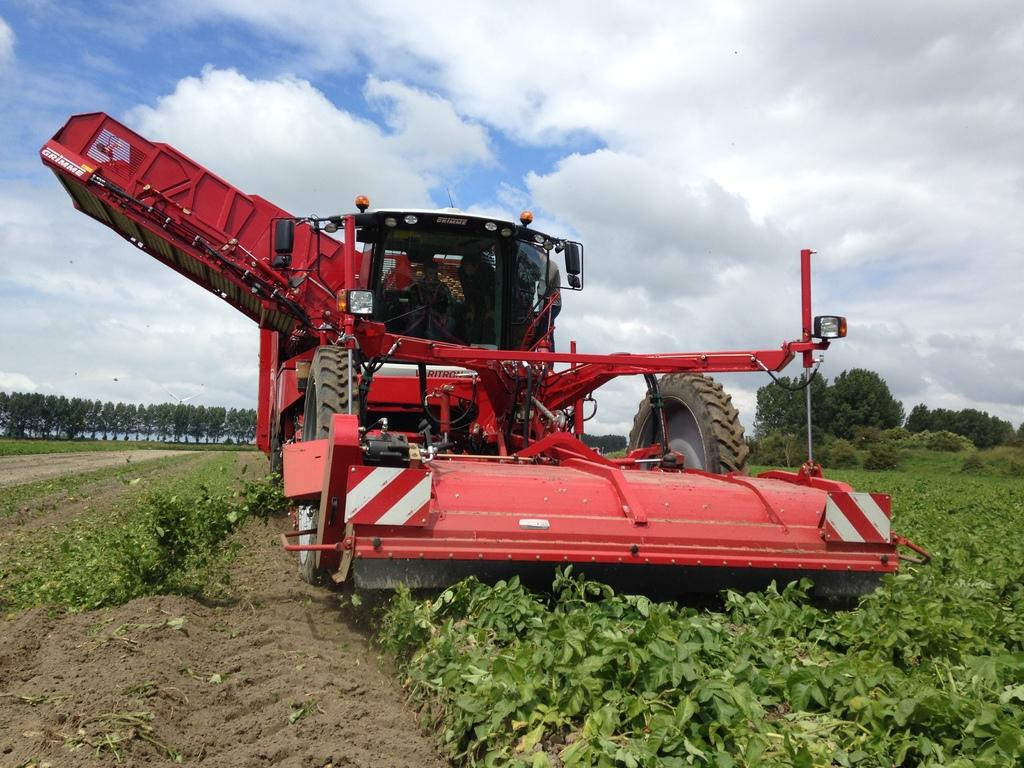What type of terrain is visible in the image? There is an open grass ground in the image. What can be seen on the grass ground? There is a red color vehicle on the grass ground. What is visible in the background of the image? There are trees and clouds visible in the background. What part of the sky is visible in the image? The sky is visible in the background. What type of jewel is being used as a base for the vehicle in the image? There is no jewel present in the image, and the vehicle is not resting on any base. 